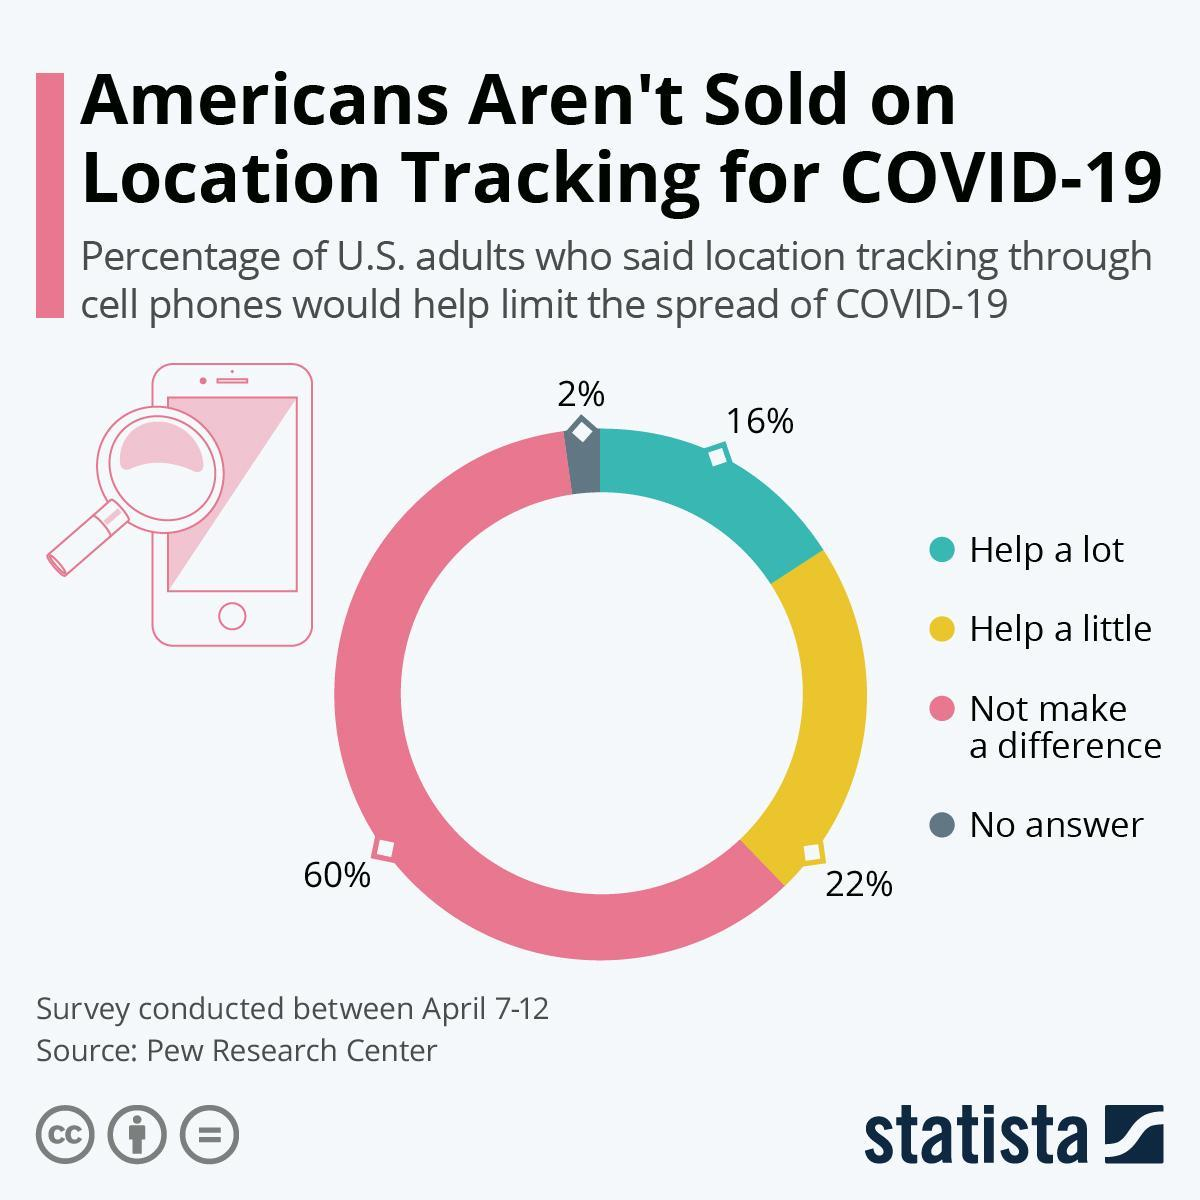What percent of people said that location tracking would not make a difference in limiting COVID-19 spread?
Answer the question with a short phrase. 60% What percent of people said that location tracking would help a lot in limiting spread of COVID-19? 16% What percent of people said that location tracking would help a little in limiting spread of COVID-19? 22% What percent of people gave no answer regarding location tracking to limit COVID-19 spread? 2% What is the combined percentage of people who think location tracking will be helpful in limiting the spread of the disease? 38% What is the opinion of majority of the Americans regarding use of location tracking to limit spread of disease? Not make a difference 